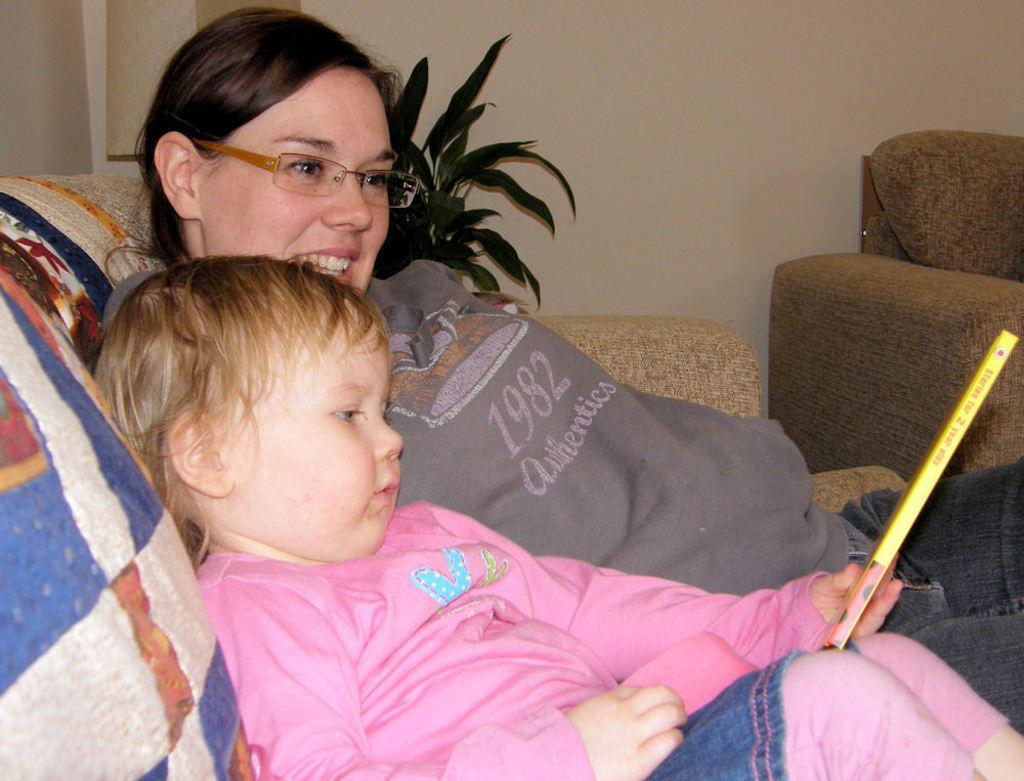Can you describe this image briefly? In this image I can see a child and a woman are sitting on a sofa. In the background I can see a plant and a wall. 